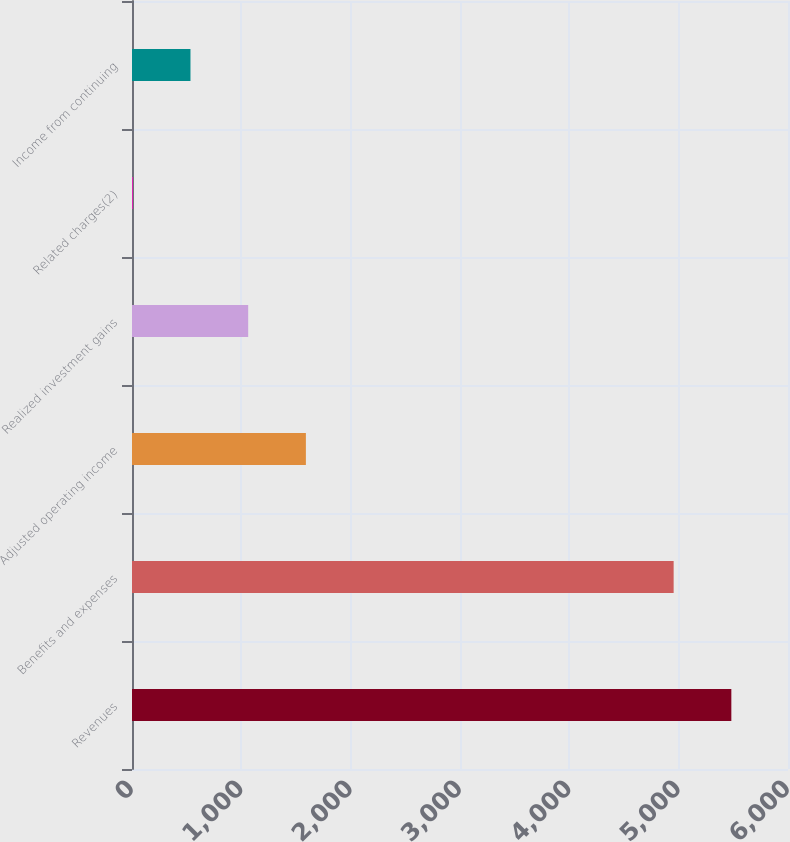Convert chart. <chart><loc_0><loc_0><loc_500><loc_500><bar_chart><fcel>Revenues<fcel>Benefits and expenses<fcel>Adjusted operating income<fcel>Realized investment gains<fcel>Related charges(2)<fcel>Income from continuing<nl><fcel>5481.8<fcel>4954<fcel>1590.4<fcel>1062.6<fcel>7<fcel>534.8<nl></chart> 